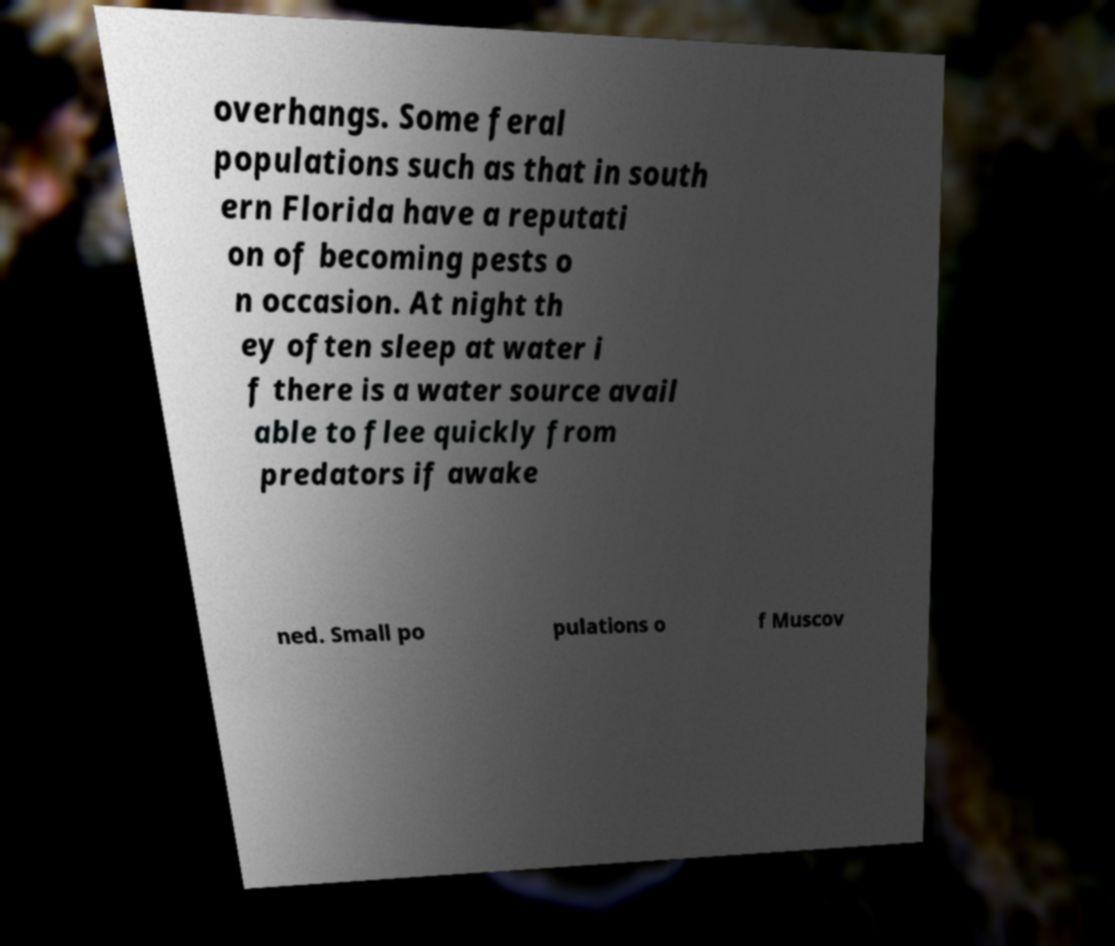Please identify and transcribe the text found in this image. overhangs. Some feral populations such as that in south ern Florida have a reputati on of becoming pests o n occasion. At night th ey often sleep at water i f there is a water source avail able to flee quickly from predators if awake ned. Small po pulations o f Muscov 